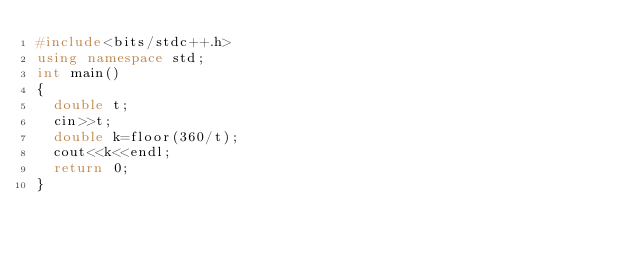Convert code to text. <code><loc_0><loc_0><loc_500><loc_500><_C++_>#include<bits/stdc++.h>
using namespace std;
int main()
{
  double t;
  cin>>t;
  double k=floor(360/t);
  cout<<k<<endl;
  return 0;
}
</code> 